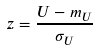<formula> <loc_0><loc_0><loc_500><loc_500>z = \frac { U - m _ { U } } { \sigma _ { U } }</formula> 